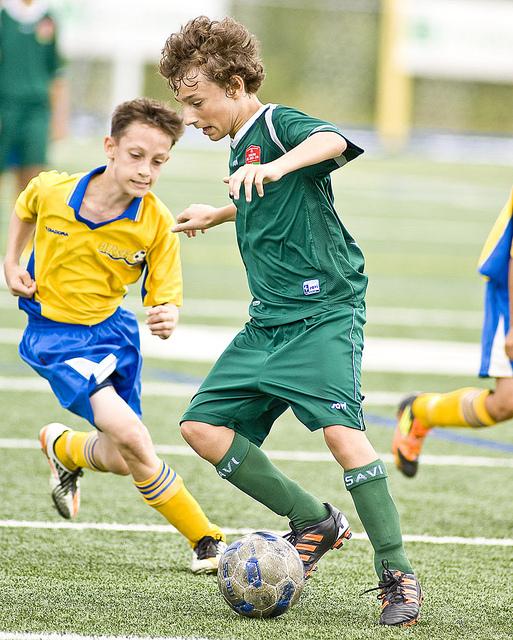What sport are these boys playing?
Concise answer only. Soccer. Are both boys on the same team?
Concise answer only. No. Are the boys playing the same team?
Concise answer only. No. 